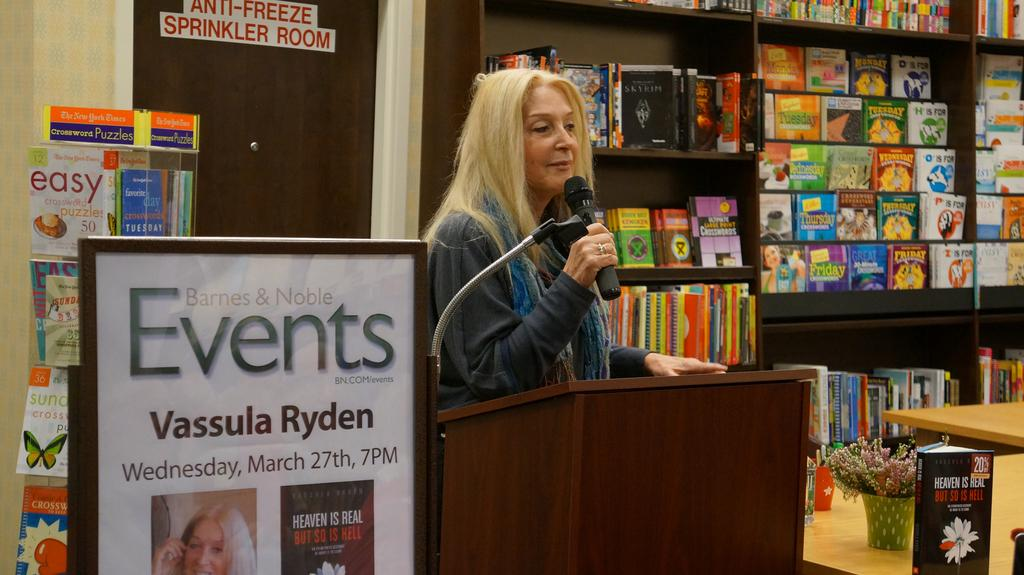<image>
Describe the image concisely. A woman next to a poster for Vassula Ryden. 